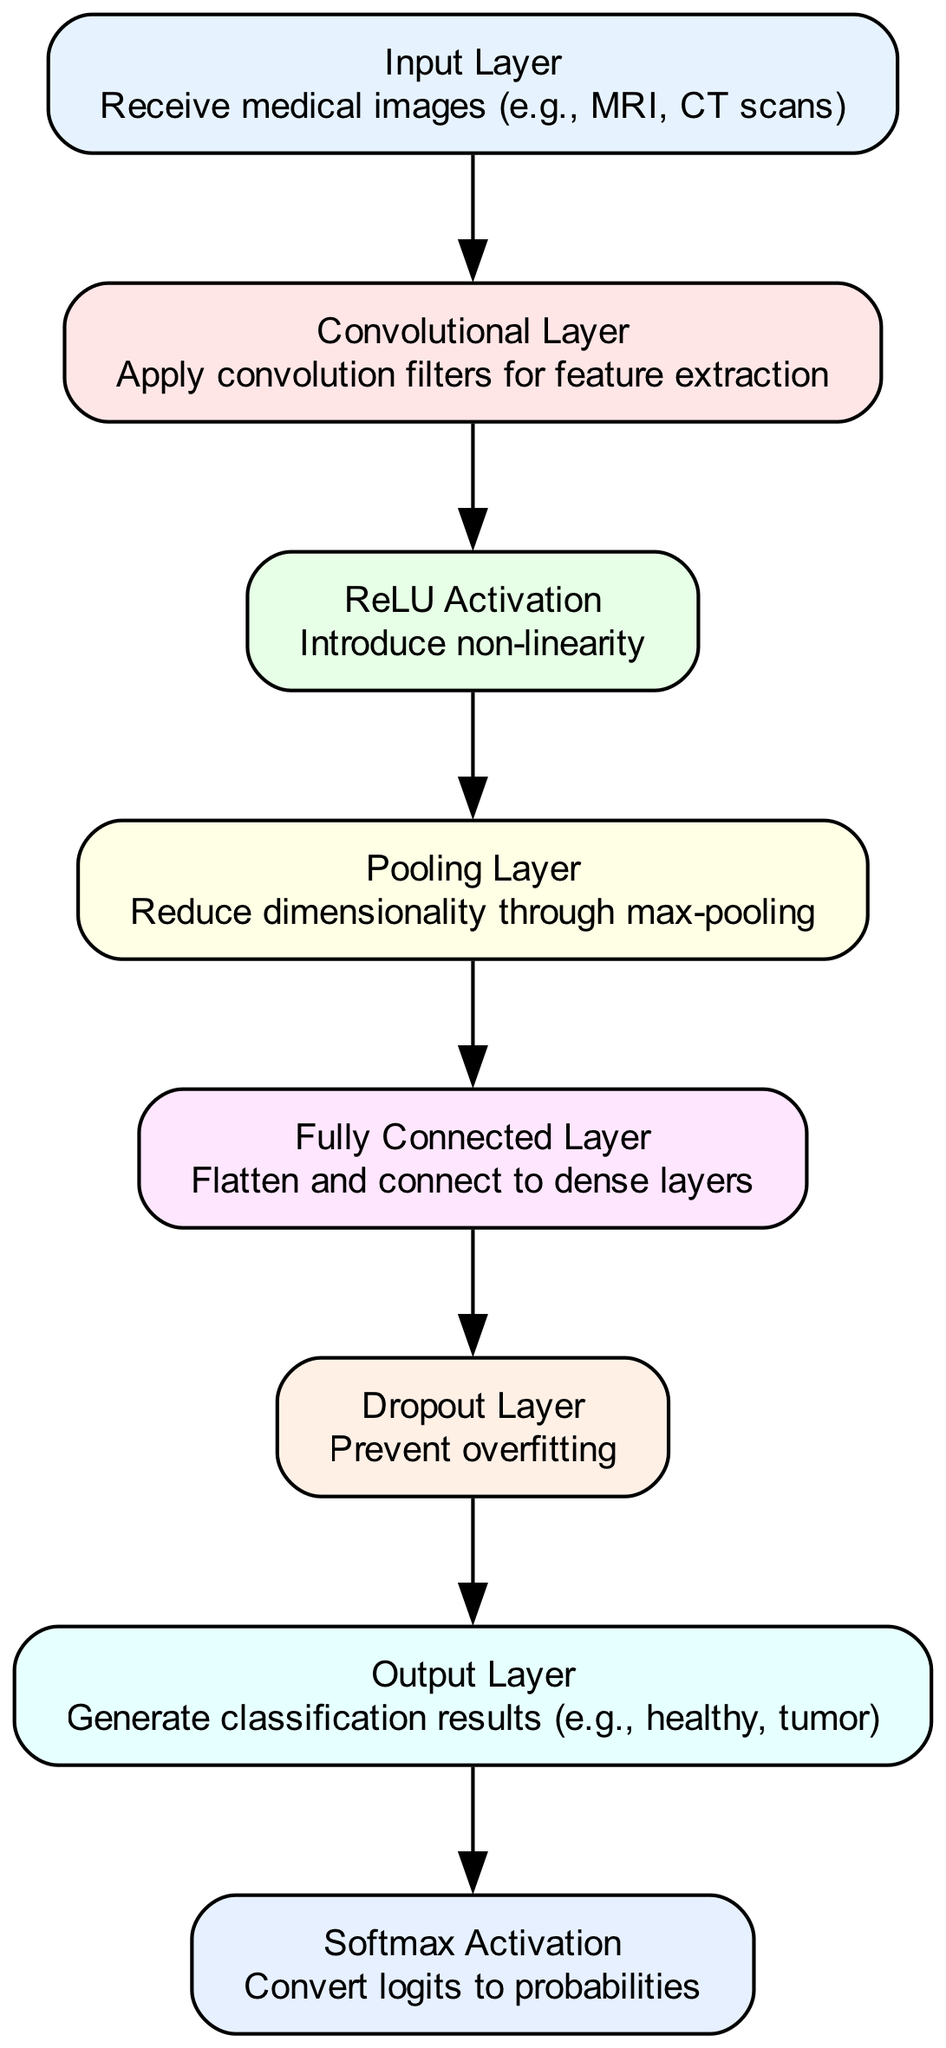What is the first layer in the neural network architecture? The first layer in the architecture is labeled "Input Layer," which is responsible for receiving medical images such as MRI or CT scans.
Answer: Input Layer How many layers are there in total? The diagram shows a total of eight layers: Input Layer, Convolutional Layer, ReLU Activation, Pooling Layer, Fully Connected Layer, Dropout Layer, Output Layer, and Softmax Activation. Counting them yields a total of eight.
Answer: Eight What is the function of the Pooling Layer? The Pooling Layer is described as reducing dimensionality through max-pooling. This implies that it takes feature maps produced by the Convolutional Layer and downsamples them, retaining only the most important features while reducing the size.
Answer: Reduce dimensionality through max-pooling Which layer comes after the Dropout Layer? The layer that follows the Dropout Layer in the architecture is the Output Layer. This indicates that the output from the Dropout Layer is fed into the Output Layer for generating results.
Answer: Output Layer What does the Softmax Activation layer do? The Softmax Activation layer converts logits to probabilities, which means it transforms the output from the final layer of the network into a probability distribution over possible classes, allowing for classification tasks.
Answer: Convert logits to probabilities How many edges are there in the diagram? The edges connect the nodes and there are a total of seven edges shown, which illustrate the flow of information from one layer to the next throughout the neural network architecture.
Answer: Seven What is the primary purpose of the Dropout Layer? The primary purpose of the Dropout Layer is to prevent overfitting. This indicates that it randomly drops a proportion of the nodes during training to enhance the generalization of the model.
Answer: Prevent overfitting What type of activation is used after the Convolutional Layer? The diagram specifies that the activation used after the Convolutional Layer is a ReLU Activation, noted for introducing non-linearity into the model, which is crucial for the network's learning capabilities.
Answer: ReLU Activation Which layer generates the final classification results? The final classification results are generated by the Output Layer, which receives input from the preceding layers and produces the final decision on the classification such as healthy or tumor.
Answer: Output Layer 